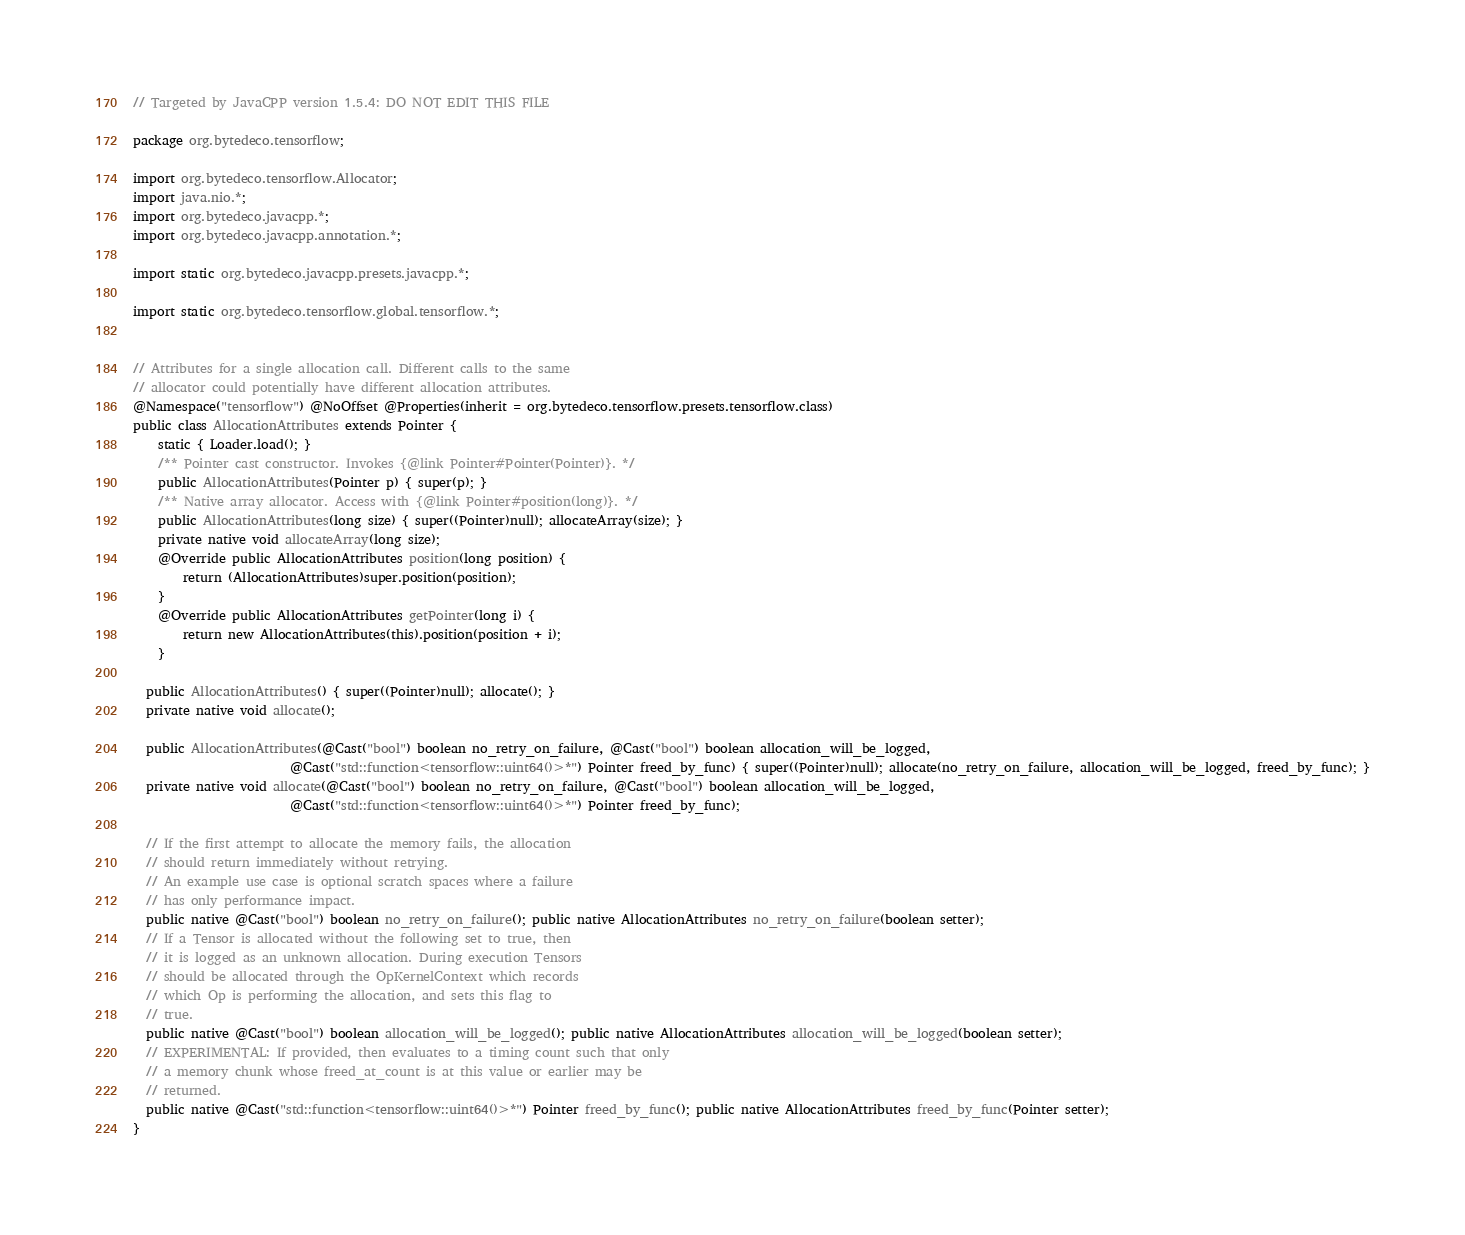Convert code to text. <code><loc_0><loc_0><loc_500><loc_500><_Java_>// Targeted by JavaCPP version 1.5.4: DO NOT EDIT THIS FILE

package org.bytedeco.tensorflow;

import org.bytedeco.tensorflow.Allocator;
import java.nio.*;
import org.bytedeco.javacpp.*;
import org.bytedeco.javacpp.annotation.*;

import static org.bytedeco.javacpp.presets.javacpp.*;

import static org.bytedeco.tensorflow.global.tensorflow.*;


// Attributes for a single allocation call. Different calls to the same
// allocator could potentially have different allocation attributes.
@Namespace("tensorflow") @NoOffset @Properties(inherit = org.bytedeco.tensorflow.presets.tensorflow.class)
public class AllocationAttributes extends Pointer {
    static { Loader.load(); }
    /** Pointer cast constructor. Invokes {@link Pointer#Pointer(Pointer)}. */
    public AllocationAttributes(Pointer p) { super(p); }
    /** Native array allocator. Access with {@link Pointer#position(long)}. */
    public AllocationAttributes(long size) { super((Pointer)null); allocateArray(size); }
    private native void allocateArray(long size);
    @Override public AllocationAttributes position(long position) {
        return (AllocationAttributes)super.position(position);
    }
    @Override public AllocationAttributes getPointer(long i) {
        return new AllocationAttributes(this).position(position + i);
    }

  public AllocationAttributes() { super((Pointer)null); allocate(); }
  private native void allocate();

  public AllocationAttributes(@Cast("bool") boolean no_retry_on_failure, @Cast("bool") boolean allocation_will_be_logged,
                         @Cast("std::function<tensorflow::uint64()>*") Pointer freed_by_func) { super((Pointer)null); allocate(no_retry_on_failure, allocation_will_be_logged, freed_by_func); }
  private native void allocate(@Cast("bool") boolean no_retry_on_failure, @Cast("bool") boolean allocation_will_be_logged,
                         @Cast("std::function<tensorflow::uint64()>*") Pointer freed_by_func);

  // If the first attempt to allocate the memory fails, the allocation
  // should return immediately without retrying.
  // An example use case is optional scratch spaces where a failure
  // has only performance impact.
  public native @Cast("bool") boolean no_retry_on_failure(); public native AllocationAttributes no_retry_on_failure(boolean setter);
  // If a Tensor is allocated without the following set to true, then
  // it is logged as an unknown allocation. During execution Tensors
  // should be allocated through the OpKernelContext which records
  // which Op is performing the allocation, and sets this flag to
  // true.
  public native @Cast("bool") boolean allocation_will_be_logged(); public native AllocationAttributes allocation_will_be_logged(boolean setter);
  // EXPERIMENTAL: If provided, then evaluates to a timing count such that only
  // a memory chunk whose freed_at_count is at this value or earlier may be
  // returned.
  public native @Cast("std::function<tensorflow::uint64()>*") Pointer freed_by_func(); public native AllocationAttributes freed_by_func(Pointer setter);
}
</code> 